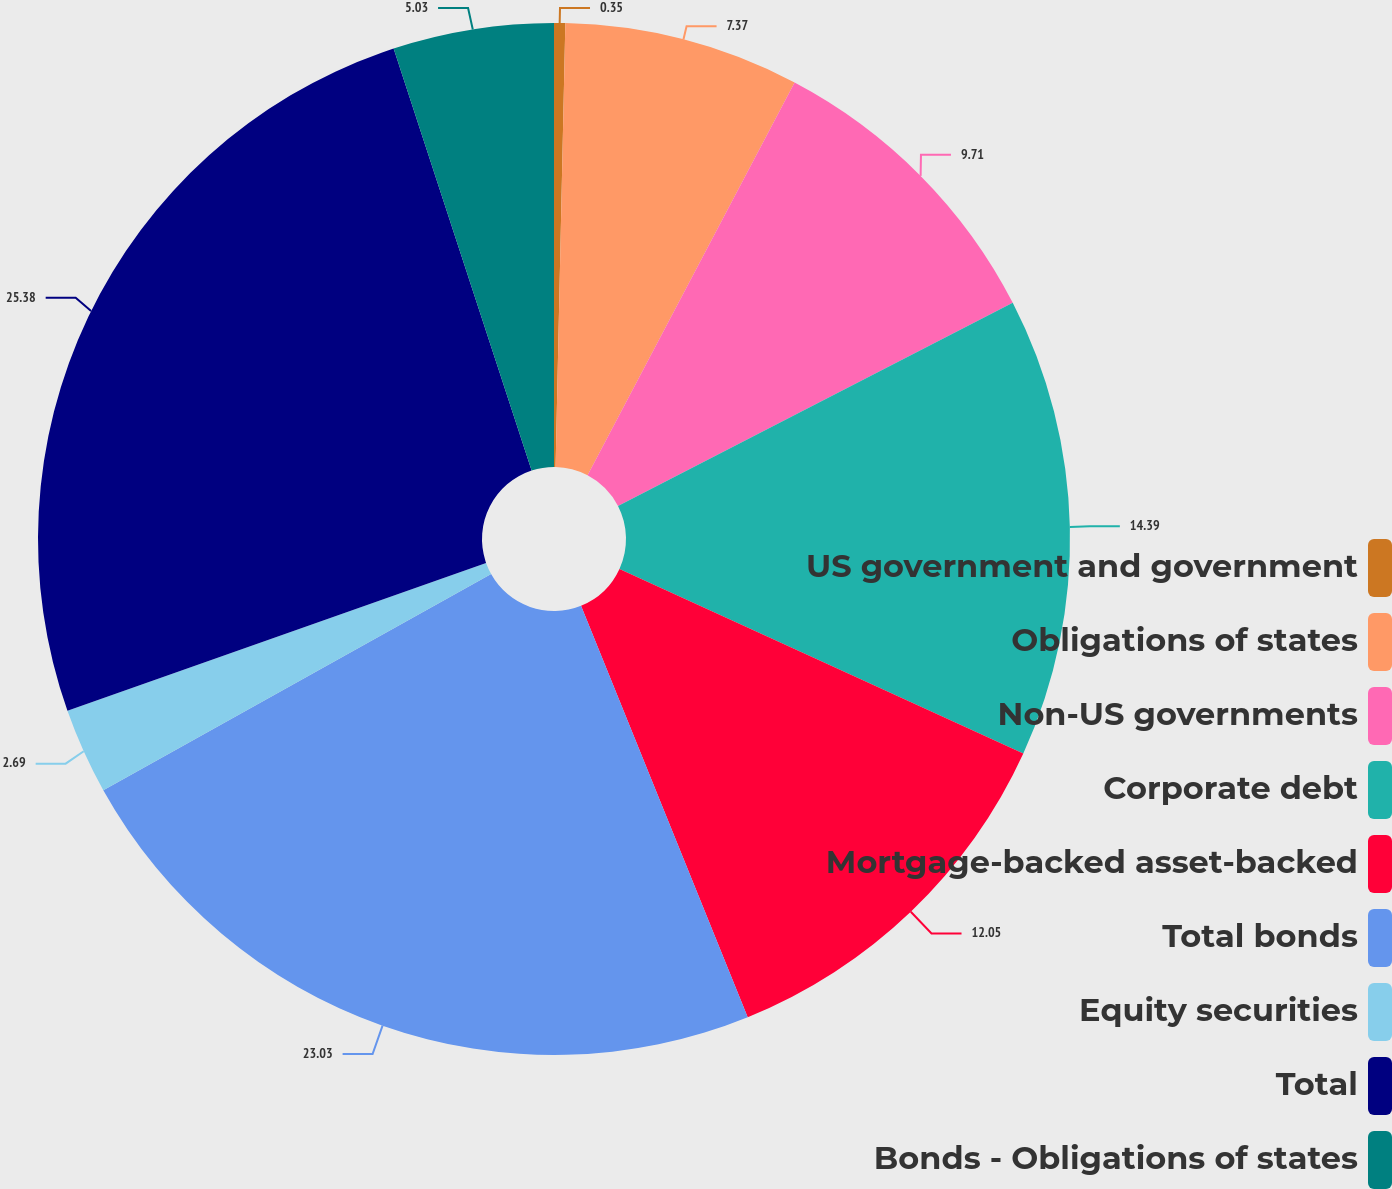Convert chart to OTSL. <chart><loc_0><loc_0><loc_500><loc_500><pie_chart><fcel>US government and government<fcel>Obligations of states<fcel>Non-US governments<fcel>Corporate debt<fcel>Mortgage-backed asset-backed<fcel>Total bonds<fcel>Equity securities<fcel>Total<fcel>Bonds - Obligations of states<nl><fcel>0.35%<fcel>7.37%<fcel>9.71%<fcel>14.39%<fcel>12.05%<fcel>23.03%<fcel>2.69%<fcel>25.37%<fcel>5.03%<nl></chart> 